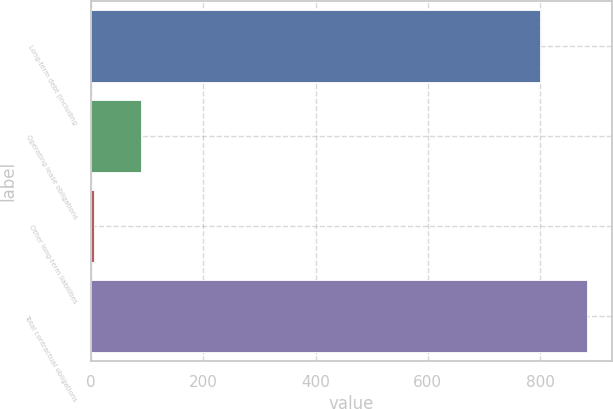Convert chart to OTSL. <chart><loc_0><loc_0><loc_500><loc_500><bar_chart><fcel>Long-term debt (including<fcel>Operating lease obligations<fcel>Other long-term liabilities<fcel>Total contractual obligations<nl><fcel>800<fcel>89.1<fcel>5<fcel>884.1<nl></chart> 